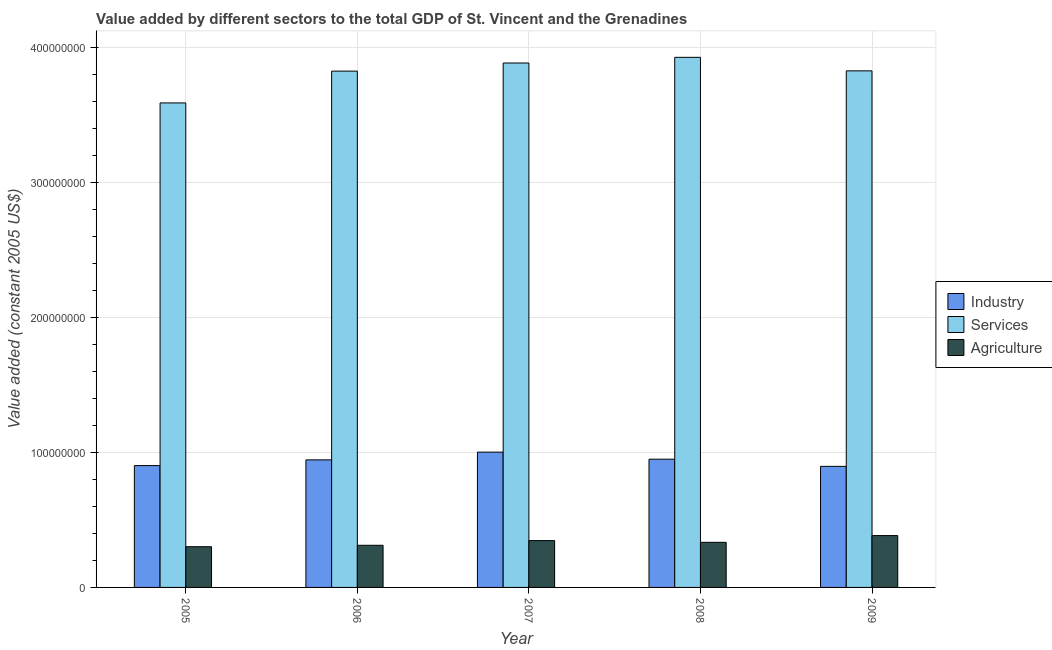How many different coloured bars are there?
Give a very brief answer. 3. How many groups of bars are there?
Ensure brevity in your answer.  5. Are the number of bars per tick equal to the number of legend labels?
Make the answer very short. Yes. Are the number of bars on each tick of the X-axis equal?
Offer a terse response. Yes. How many bars are there on the 1st tick from the left?
Make the answer very short. 3. What is the label of the 5th group of bars from the left?
Provide a succinct answer. 2009. In how many cases, is the number of bars for a given year not equal to the number of legend labels?
Keep it short and to the point. 0. What is the value added by agricultural sector in 2007?
Make the answer very short. 3.47e+07. Across all years, what is the maximum value added by services?
Ensure brevity in your answer.  3.93e+08. Across all years, what is the minimum value added by services?
Your answer should be compact. 3.59e+08. In which year was the value added by industrial sector maximum?
Offer a very short reply. 2007. In which year was the value added by agricultural sector minimum?
Ensure brevity in your answer.  2005. What is the total value added by industrial sector in the graph?
Your response must be concise. 4.70e+08. What is the difference between the value added by industrial sector in 2005 and that in 2007?
Keep it short and to the point. -9.96e+06. What is the difference between the value added by industrial sector in 2006 and the value added by agricultural sector in 2008?
Provide a succinct answer. -5.05e+05. What is the average value added by industrial sector per year?
Offer a very short reply. 9.39e+07. What is the ratio of the value added by industrial sector in 2006 to that in 2007?
Your response must be concise. 0.94. Is the value added by agricultural sector in 2006 less than that in 2007?
Provide a succinct answer. Yes. Is the difference between the value added by services in 2008 and 2009 greater than the difference between the value added by agricultural sector in 2008 and 2009?
Keep it short and to the point. No. What is the difference between the highest and the second highest value added by services?
Keep it short and to the point. 4.21e+06. What is the difference between the highest and the lowest value added by agricultural sector?
Your answer should be very brief. 8.26e+06. What does the 3rd bar from the left in 2005 represents?
Provide a succinct answer. Agriculture. What does the 1st bar from the right in 2006 represents?
Your answer should be compact. Agriculture. Is it the case that in every year, the sum of the value added by industrial sector and value added by services is greater than the value added by agricultural sector?
Provide a short and direct response. Yes. How many years are there in the graph?
Your answer should be compact. 5. Are the values on the major ticks of Y-axis written in scientific E-notation?
Your answer should be very brief. No. How many legend labels are there?
Provide a succinct answer. 3. What is the title of the graph?
Provide a short and direct response. Value added by different sectors to the total GDP of St. Vincent and the Grenadines. What is the label or title of the Y-axis?
Your answer should be compact. Value added (constant 2005 US$). What is the Value added (constant 2005 US$) in Industry in 2005?
Provide a short and direct response. 9.02e+07. What is the Value added (constant 2005 US$) of Services in 2005?
Provide a short and direct response. 3.59e+08. What is the Value added (constant 2005 US$) of Agriculture in 2005?
Keep it short and to the point. 3.01e+07. What is the Value added (constant 2005 US$) in Industry in 2006?
Give a very brief answer. 9.45e+07. What is the Value added (constant 2005 US$) of Services in 2006?
Offer a very short reply. 3.82e+08. What is the Value added (constant 2005 US$) of Agriculture in 2006?
Your answer should be very brief. 3.12e+07. What is the Value added (constant 2005 US$) of Industry in 2007?
Keep it short and to the point. 1.00e+08. What is the Value added (constant 2005 US$) of Services in 2007?
Offer a terse response. 3.88e+08. What is the Value added (constant 2005 US$) of Agriculture in 2007?
Make the answer very short. 3.47e+07. What is the Value added (constant 2005 US$) of Industry in 2008?
Ensure brevity in your answer.  9.50e+07. What is the Value added (constant 2005 US$) in Services in 2008?
Your response must be concise. 3.93e+08. What is the Value added (constant 2005 US$) in Agriculture in 2008?
Make the answer very short. 3.34e+07. What is the Value added (constant 2005 US$) in Industry in 2009?
Your answer should be very brief. 8.97e+07. What is the Value added (constant 2005 US$) of Services in 2009?
Offer a terse response. 3.83e+08. What is the Value added (constant 2005 US$) in Agriculture in 2009?
Make the answer very short. 3.84e+07. Across all years, what is the maximum Value added (constant 2005 US$) in Industry?
Your answer should be very brief. 1.00e+08. Across all years, what is the maximum Value added (constant 2005 US$) in Services?
Your response must be concise. 3.93e+08. Across all years, what is the maximum Value added (constant 2005 US$) in Agriculture?
Your answer should be compact. 3.84e+07. Across all years, what is the minimum Value added (constant 2005 US$) of Industry?
Offer a very short reply. 8.97e+07. Across all years, what is the minimum Value added (constant 2005 US$) in Services?
Keep it short and to the point. 3.59e+08. Across all years, what is the minimum Value added (constant 2005 US$) in Agriculture?
Offer a terse response. 3.01e+07. What is the total Value added (constant 2005 US$) of Industry in the graph?
Offer a very short reply. 4.70e+08. What is the total Value added (constant 2005 US$) in Services in the graph?
Make the answer very short. 1.90e+09. What is the total Value added (constant 2005 US$) in Agriculture in the graph?
Keep it short and to the point. 1.68e+08. What is the difference between the Value added (constant 2005 US$) in Industry in 2005 and that in 2006?
Provide a succinct answer. -4.23e+06. What is the difference between the Value added (constant 2005 US$) in Services in 2005 and that in 2006?
Your answer should be compact. -2.36e+07. What is the difference between the Value added (constant 2005 US$) in Agriculture in 2005 and that in 2006?
Make the answer very short. -1.06e+06. What is the difference between the Value added (constant 2005 US$) of Industry in 2005 and that in 2007?
Give a very brief answer. -9.96e+06. What is the difference between the Value added (constant 2005 US$) of Services in 2005 and that in 2007?
Your answer should be very brief. -2.96e+07. What is the difference between the Value added (constant 2005 US$) of Agriculture in 2005 and that in 2007?
Your answer should be very brief. -4.53e+06. What is the difference between the Value added (constant 2005 US$) in Industry in 2005 and that in 2008?
Offer a very short reply. -4.73e+06. What is the difference between the Value added (constant 2005 US$) of Services in 2005 and that in 2008?
Keep it short and to the point. -3.38e+07. What is the difference between the Value added (constant 2005 US$) of Agriculture in 2005 and that in 2008?
Make the answer very short. -3.26e+06. What is the difference between the Value added (constant 2005 US$) in Industry in 2005 and that in 2009?
Offer a very short reply. 5.81e+05. What is the difference between the Value added (constant 2005 US$) in Services in 2005 and that in 2009?
Provide a short and direct response. -2.37e+07. What is the difference between the Value added (constant 2005 US$) of Agriculture in 2005 and that in 2009?
Ensure brevity in your answer.  -8.26e+06. What is the difference between the Value added (constant 2005 US$) in Industry in 2006 and that in 2007?
Offer a very short reply. -5.74e+06. What is the difference between the Value added (constant 2005 US$) in Services in 2006 and that in 2007?
Offer a terse response. -6.01e+06. What is the difference between the Value added (constant 2005 US$) of Agriculture in 2006 and that in 2007?
Your answer should be compact. -3.48e+06. What is the difference between the Value added (constant 2005 US$) of Industry in 2006 and that in 2008?
Ensure brevity in your answer.  -5.05e+05. What is the difference between the Value added (constant 2005 US$) in Services in 2006 and that in 2008?
Offer a terse response. -1.02e+07. What is the difference between the Value added (constant 2005 US$) of Agriculture in 2006 and that in 2008?
Your response must be concise. -2.20e+06. What is the difference between the Value added (constant 2005 US$) in Industry in 2006 and that in 2009?
Your response must be concise. 4.81e+06. What is the difference between the Value added (constant 2005 US$) of Services in 2006 and that in 2009?
Your answer should be very brief. -1.94e+05. What is the difference between the Value added (constant 2005 US$) of Agriculture in 2006 and that in 2009?
Make the answer very short. -7.20e+06. What is the difference between the Value added (constant 2005 US$) in Industry in 2007 and that in 2008?
Offer a very short reply. 5.23e+06. What is the difference between the Value added (constant 2005 US$) of Services in 2007 and that in 2008?
Ensure brevity in your answer.  -4.21e+06. What is the difference between the Value added (constant 2005 US$) in Agriculture in 2007 and that in 2008?
Offer a very short reply. 1.27e+06. What is the difference between the Value added (constant 2005 US$) in Industry in 2007 and that in 2009?
Provide a short and direct response. 1.05e+07. What is the difference between the Value added (constant 2005 US$) in Services in 2007 and that in 2009?
Make the answer very short. 5.81e+06. What is the difference between the Value added (constant 2005 US$) of Agriculture in 2007 and that in 2009?
Your answer should be very brief. -3.72e+06. What is the difference between the Value added (constant 2005 US$) of Industry in 2008 and that in 2009?
Make the answer very short. 5.31e+06. What is the difference between the Value added (constant 2005 US$) in Services in 2008 and that in 2009?
Give a very brief answer. 1.00e+07. What is the difference between the Value added (constant 2005 US$) of Agriculture in 2008 and that in 2009?
Offer a very short reply. -5.00e+06. What is the difference between the Value added (constant 2005 US$) of Industry in 2005 and the Value added (constant 2005 US$) of Services in 2006?
Offer a very short reply. -2.92e+08. What is the difference between the Value added (constant 2005 US$) in Industry in 2005 and the Value added (constant 2005 US$) in Agriculture in 2006?
Provide a short and direct response. 5.90e+07. What is the difference between the Value added (constant 2005 US$) of Services in 2005 and the Value added (constant 2005 US$) of Agriculture in 2006?
Offer a terse response. 3.28e+08. What is the difference between the Value added (constant 2005 US$) of Industry in 2005 and the Value added (constant 2005 US$) of Services in 2007?
Keep it short and to the point. -2.98e+08. What is the difference between the Value added (constant 2005 US$) of Industry in 2005 and the Value added (constant 2005 US$) of Agriculture in 2007?
Provide a short and direct response. 5.56e+07. What is the difference between the Value added (constant 2005 US$) of Services in 2005 and the Value added (constant 2005 US$) of Agriculture in 2007?
Make the answer very short. 3.24e+08. What is the difference between the Value added (constant 2005 US$) in Industry in 2005 and the Value added (constant 2005 US$) in Services in 2008?
Your answer should be compact. -3.02e+08. What is the difference between the Value added (constant 2005 US$) in Industry in 2005 and the Value added (constant 2005 US$) in Agriculture in 2008?
Offer a very short reply. 5.68e+07. What is the difference between the Value added (constant 2005 US$) in Services in 2005 and the Value added (constant 2005 US$) in Agriculture in 2008?
Provide a short and direct response. 3.25e+08. What is the difference between the Value added (constant 2005 US$) in Industry in 2005 and the Value added (constant 2005 US$) in Services in 2009?
Provide a short and direct response. -2.92e+08. What is the difference between the Value added (constant 2005 US$) of Industry in 2005 and the Value added (constant 2005 US$) of Agriculture in 2009?
Make the answer very short. 5.18e+07. What is the difference between the Value added (constant 2005 US$) in Services in 2005 and the Value added (constant 2005 US$) in Agriculture in 2009?
Your answer should be compact. 3.20e+08. What is the difference between the Value added (constant 2005 US$) in Industry in 2006 and the Value added (constant 2005 US$) in Services in 2007?
Your answer should be compact. -2.94e+08. What is the difference between the Value added (constant 2005 US$) of Industry in 2006 and the Value added (constant 2005 US$) of Agriculture in 2007?
Your response must be concise. 5.98e+07. What is the difference between the Value added (constant 2005 US$) of Services in 2006 and the Value added (constant 2005 US$) of Agriculture in 2007?
Your answer should be very brief. 3.48e+08. What is the difference between the Value added (constant 2005 US$) in Industry in 2006 and the Value added (constant 2005 US$) in Services in 2008?
Your answer should be very brief. -2.98e+08. What is the difference between the Value added (constant 2005 US$) of Industry in 2006 and the Value added (constant 2005 US$) of Agriculture in 2008?
Your answer should be very brief. 6.11e+07. What is the difference between the Value added (constant 2005 US$) of Services in 2006 and the Value added (constant 2005 US$) of Agriculture in 2008?
Your response must be concise. 3.49e+08. What is the difference between the Value added (constant 2005 US$) in Industry in 2006 and the Value added (constant 2005 US$) in Services in 2009?
Your answer should be very brief. -2.88e+08. What is the difference between the Value added (constant 2005 US$) of Industry in 2006 and the Value added (constant 2005 US$) of Agriculture in 2009?
Keep it short and to the point. 5.61e+07. What is the difference between the Value added (constant 2005 US$) in Services in 2006 and the Value added (constant 2005 US$) in Agriculture in 2009?
Your response must be concise. 3.44e+08. What is the difference between the Value added (constant 2005 US$) in Industry in 2007 and the Value added (constant 2005 US$) in Services in 2008?
Your response must be concise. -2.92e+08. What is the difference between the Value added (constant 2005 US$) in Industry in 2007 and the Value added (constant 2005 US$) in Agriculture in 2008?
Provide a succinct answer. 6.68e+07. What is the difference between the Value added (constant 2005 US$) in Services in 2007 and the Value added (constant 2005 US$) in Agriculture in 2008?
Make the answer very short. 3.55e+08. What is the difference between the Value added (constant 2005 US$) of Industry in 2007 and the Value added (constant 2005 US$) of Services in 2009?
Offer a very short reply. -2.82e+08. What is the difference between the Value added (constant 2005 US$) of Industry in 2007 and the Value added (constant 2005 US$) of Agriculture in 2009?
Make the answer very short. 6.18e+07. What is the difference between the Value added (constant 2005 US$) of Services in 2007 and the Value added (constant 2005 US$) of Agriculture in 2009?
Your answer should be very brief. 3.50e+08. What is the difference between the Value added (constant 2005 US$) of Industry in 2008 and the Value added (constant 2005 US$) of Services in 2009?
Your answer should be compact. -2.88e+08. What is the difference between the Value added (constant 2005 US$) in Industry in 2008 and the Value added (constant 2005 US$) in Agriculture in 2009?
Offer a terse response. 5.66e+07. What is the difference between the Value added (constant 2005 US$) of Services in 2008 and the Value added (constant 2005 US$) of Agriculture in 2009?
Make the answer very short. 3.54e+08. What is the average Value added (constant 2005 US$) of Industry per year?
Offer a terse response. 9.39e+07. What is the average Value added (constant 2005 US$) of Services per year?
Give a very brief answer. 3.81e+08. What is the average Value added (constant 2005 US$) of Agriculture per year?
Keep it short and to the point. 3.36e+07. In the year 2005, what is the difference between the Value added (constant 2005 US$) in Industry and Value added (constant 2005 US$) in Services?
Provide a short and direct response. -2.69e+08. In the year 2005, what is the difference between the Value added (constant 2005 US$) of Industry and Value added (constant 2005 US$) of Agriculture?
Offer a very short reply. 6.01e+07. In the year 2005, what is the difference between the Value added (constant 2005 US$) of Services and Value added (constant 2005 US$) of Agriculture?
Your answer should be very brief. 3.29e+08. In the year 2006, what is the difference between the Value added (constant 2005 US$) in Industry and Value added (constant 2005 US$) in Services?
Provide a succinct answer. -2.88e+08. In the year 2006, what is the difference between the Value added (constant 2005 US$) in Industry and Value added (constant 2005 US$) in Agriculture?
Make the answer very short. 6.33e+07. In the year 2006, what is the difference between the Value added (constant 2005 US$) of Services and Value added (constant 2005 US$) of Agriculture?
Provide a short and direct response. 3.51e+08. In the year 2007, what is the difference between the Value added (constant 2005 US$) in Industry and Value added (constant 2005 US$) in Services?
Your response must be concise. -2.88e+08. In the year 2007, what is the difference between the Value added (constant 2005 US$) in Industry and Value added (constant 2005 US$) in Agriculture?
Make the answer very short. 6.55e+07. In the year 2007, what is the difference between the Value added (constant 2005 US$) of Services and Value added (constant 2005 US$) of Agriculture?
Your answer should be compact. 3.54e+08. In the year 2008, what is the difference between the Value added (constant 2005 US$) in Industry and Value added (constant 2005 US$) in Services?
Your answer should be compact. -2.98e+08. In the year 2008, what is the difference between the Value added (constant 2005 US$) of Industry and Value added (constant 2005 US$) of Agriculture?
Ensure brevity in your answer.  6.16e+07. In the year 2008, what is the difference between the Value added (constant 2005 US$) of Services and Value added (constant 2005 US$) of Agriculture?
Offer a terse response. 3.59e+08. In the year 2009, what is the difference between the Value added (constant 2005 US$) of Industry and Value added (constant 2005 US$) of Services?
Your response must be concise. -2.93e+08. In the year 2009, what is the difference between the Value added (constant 2005 US$) of Industry and Value added (constant 2005 US$) of Agriculture?
Your answer should be very brief. 5.12e+07. In the year 2009, what is the difference between the Value added (constant 2005 US$) in Services and Value added (constant 2005 US$) in Agriculture?
Offer a terse response. 3.44e+08. What is the ratio of the Value added (constant 2005 US$) of Industry in 2005 to that in 2006?
Ensure brevity in your answer.  0.96. What is the ratio of the Value added (constant 2005 US$) in Services in 2005 to that in 2006?
Provide a short and direct response. 0.94. What is the ratio of the Value added (constant 2005 US$) of Agriculture in 2005 to that in 2006?
Your response must be concise. 0.97. What is the ratio of the Value added (constant 2005 US$) of Industry in 2005 to that in 2007?
Give a very brief answer. 0.9. What is the ratio of the Value added (constant 2005 US$) in Services in 2005 to that in 2007?
Make the answer very short. 0.92. What is the ratio of the Value added (constant 2005 US$) in Agriculture in 2005 to that in 2007?
Keep it short and to the point. 0.87. What is the ratio of the Value added (constant 2005 US$) of Industry in 2005 to that in 2008?
Ensure brevity in your answer.  0.95. What is the ratio of the Value added (constant 2005 US$) of Services in 2005 to that in 2008?
Offer a very short reply. 0.91. What is the ratio of the Value added (constant 2005 US$) of Agriculture in 2005 to that in 2008?
Offer a terse response. 0.9. What is the ratio of the Value added (constant 2005 US$) in Industry in 2005 to that in 2009?
Keep it short and to the point. 1.01. What is the ratio of the Value added (constant 2005 US$) in Services in 2005 to that in 2009?
Your response must be concise. 0.94. What is the ratio of the Value added (constant 2005 US$) of Agriculture in 2005 to that in 2009?
Your answer should be very brief. 0.79. What is the ratio of the Value added (constant 2005 US$) of Industry in 2006 to that in 2007?
Keep it short and to the point. 0.94. What is the ratio of the Value added (constant 2005 US$) of Services in 2006 to that in 2007?
Your response must be concise. 0.98. What is the ratio of the Value added (constant 2005 US$) of Agriculture in 2006 to that in 2007?
Provide a short and direct response. 0.9. What is the ratio of the Value added (constant 2005 US$) in Services in 2006 to that in 2008?
Your answer should be compact. 0.97. What is the ratio of the Value added (constant 2005 US$) in Agriculture in 2006 to that in 2008?
Provide a succinct answer. 0.93. What is the ratio of the Value added (constant 2005 US$) in Industry in 2006 to that in 2009?
Ensure brevity in your answer.  1.05. What is the ratio of the Value added (constant 2005 US$) in Agriculture in 2006 to that in 2009?
Your answer should be compact. 0.81. What is the ratio of the Value added (constant 2005 US$) in Industry in 2007 to that in 2008?
Keep it short and to the point. 1.06. What is the ratio of the Value added (constant 2005 US$) of Services in 2007 to that in 2008?
Make the answer very short. 0.99. What is the ratio of the Value added (constant 2005 US$) in Agriculture in 2007 to that in 2008?
Offer a terse response. 1.04. What is the ratio of the Value added (constant 2005 US$) in Industry in 2007 to that in 2009?
Keep it short and to the point. 1.12. What is the ratio of the Value added (constant 2005 US$) in Services in 2007 to that in 2009?
Give a very brief answer. 1.02. What is the ratio of the Value added (constant 2005 US$) of Agriculture in 2007 to that in 2009?
Your answer should be very brief. 0.9. What is the ratio of the Value added (constant 2005 US$) of Industry in 2008 to that in 2009?
Give a very brief answer. 1.06. What is the ratio of the Value added (constant 2005 US$) in Services in 2008 to that in 2009?
Your answer should be very brief. 1.03. What is the ratio of the Value added (constant 2005 US$) of Agriculture in 2008 to that in 2009?
Keep it short and to the point. 0.87. What is the difference between the highest and the second highest Value added (constant 2005 US$) of Industry?
Provide a short and direct response. 5.23e+06. What is the difference between the highest and the second highest Value added (constant 2005 US$) in Services?
Your answer should be compact. 4.21e+06. What is the difference between the highest and the second highest Value added (constant 2005 US$) in Agriculture?
Make the answer very short. 3.72e+06. What is the difference between the highest and the lowest Value added (constant 2005 US$) in Industry?
Offer a very short reply. 1.05e+07. What is the difference between the highest and the lowest Value added (constant 2005 US$) of Services?
Ensure brevity in your answer.  3.38e+07. What is the difference between the highest and the lowest Value added (constant 2005 US$) in Agriculture?
Give a very brief answer. 8.26e+06. 